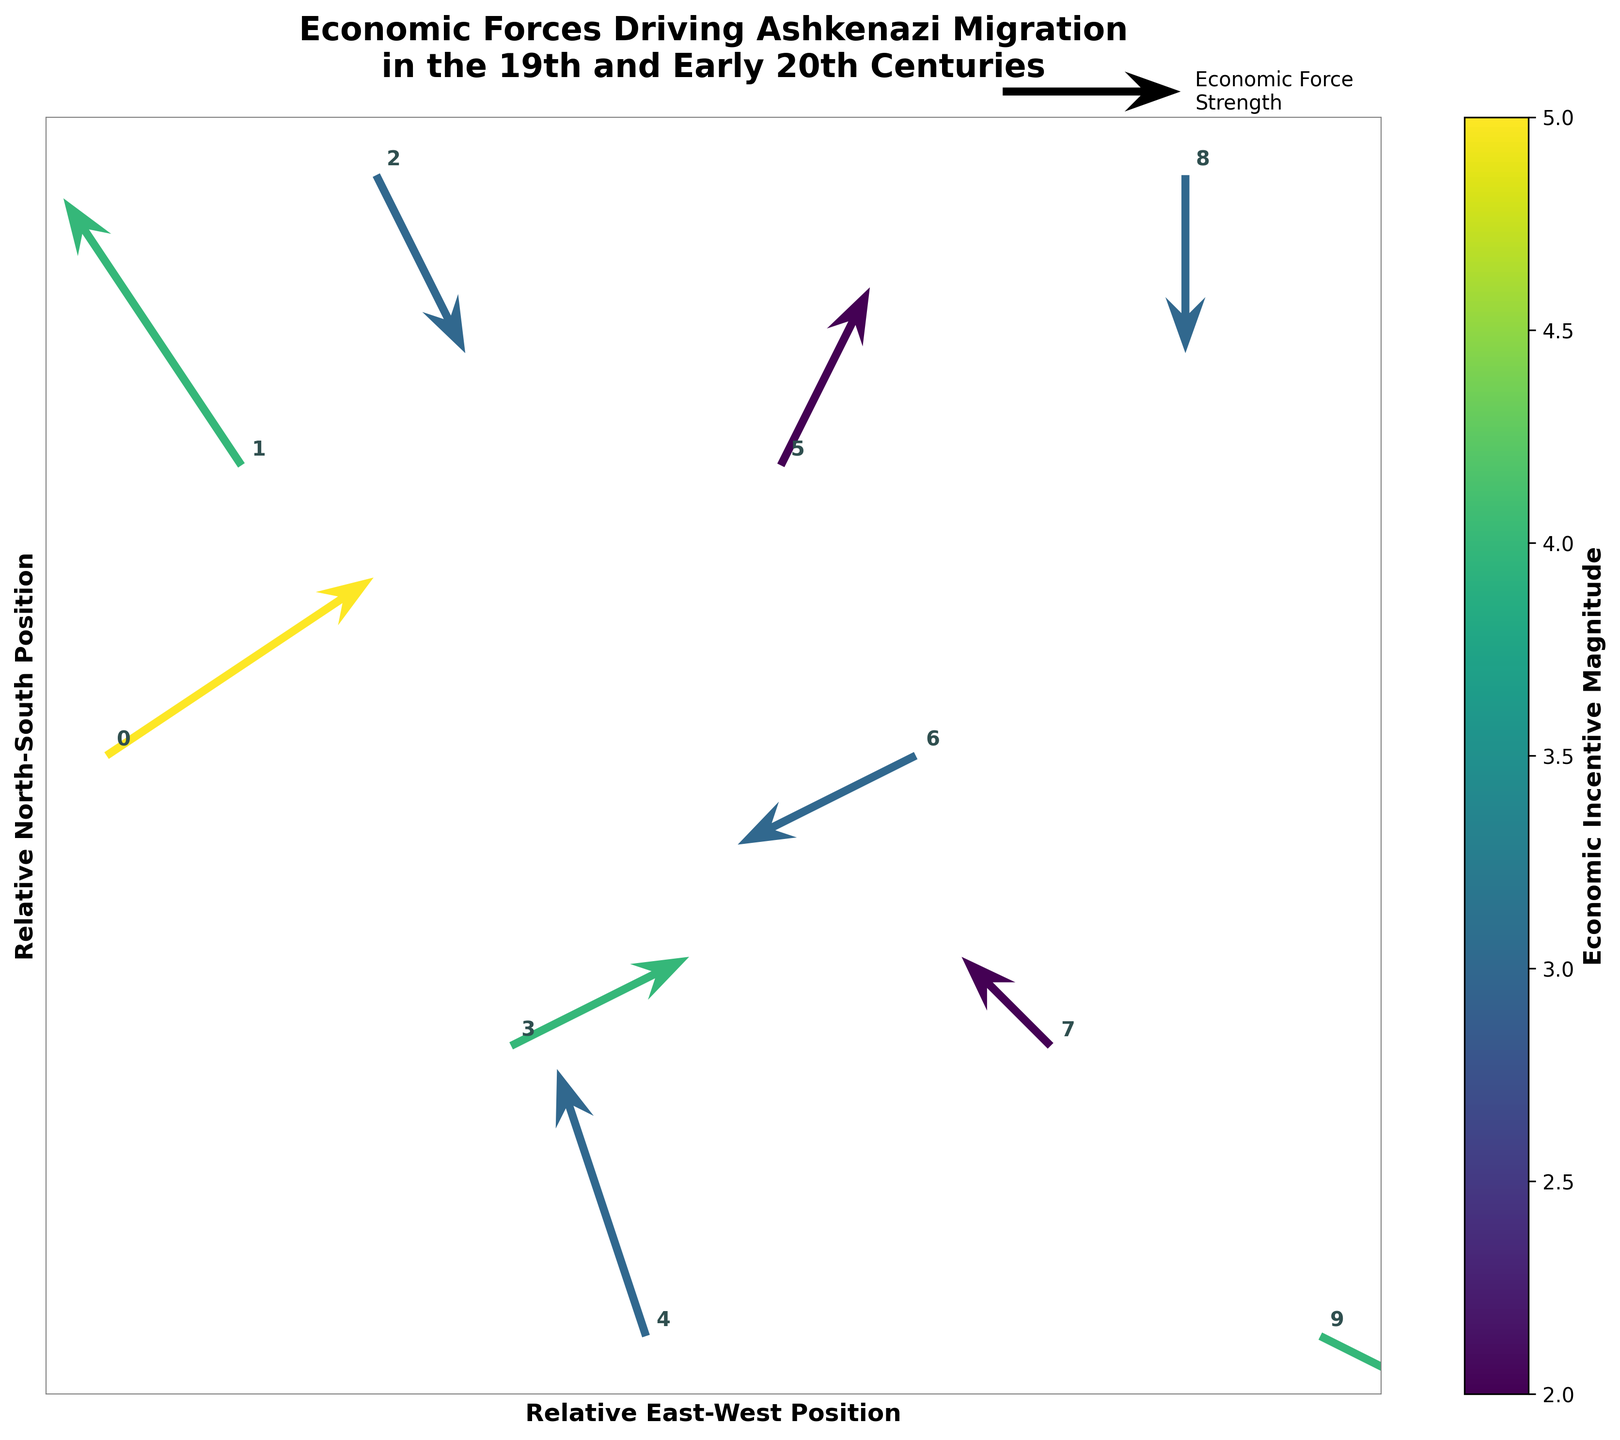How many cities are marked on the quiver plot? Count the number of city labels annotated on the plot. Each city represents a data point, and there are 10 cities in total: Warsaw, Odessa, Vienna, Berlin, Lviv, Krakow, Budapest, Prague, Frankfurt, and Vilnius.
Answer: 10 Which city shows the highest economic incentive magnitude? Check the color bar legend and the corresponding colors of arrows. The city of Warsaw has the most intense color, indicating the highest magnitude of 5.
Answer: Warsaw What is the direction of economic forces in Odessa? Examine the arrow starting from Odessa. It points in the direction of (-2, 3), meaning westwards and northwards.
Answer: Westwards and northwards Which cities experience an economic force moving eastwards? Identify cities with arrows pointing to the right (positive x-direction): Warsaw, Krakow, and Lviv.
Answer: Warsaw, Krakow, and Lviv Compare the economic force strength between Vienna and Budapest. Which is stronger? Look at the color intensity of the arrows for both cities. The arrow for Vienna has a lower magnitude of 3 compared to Budapest's magnitude of 3. Although magnitudes are visually coded similarly, the arrow itself should be compared directly to identify any disparities. However, as the colors are quite similar, further numerical comparison based on data confirms equivalence.
Answer: Equal Which directions do the economic forces act upon Lviv and Frankfurt? Examine the arrows for both cities. Lviv has an arrow pointing southwest (-1, 3) and Frankfurt’s arrow points west (-2, 0).
Answer: Southwest and West Are the economic incentives for Ashkenazi migration stronger in cities located geographically more to the east or west? Assess the color intensity of arrows on the left (east) side of the plot compared to those on the right (west). The eastern cities like Warsaw and Odessa show higher magnitudes than western cities like Vienna and Frankfurt.
Answer: East Which city has an economic force directed southwards? Identify cities with arrows pointing down (negative y-direction). Odessa and Budapest show arrows pointing downwards.
Answer: Odessa and Budapest Is there any city where the economic force is directed purely horizontally (either east or west)? Look for arrows that point entirely along the x-axis (y-component of 0). Frankfurt's arrow points west, fitting this criterion.
Answer: Frankfurt Compare the overall migration incentive strength in Polish cities shown on the plot. The Polish cities are Warsaw, Krakow, and Lviv. Check their magnitudes: Warsaw (5), Krakow (2), and Lviv (3); thus, Warsaw has the highest strength, followed by Lviv and then Krakow.
Answer: Warsaw > Lviv > Krakow 